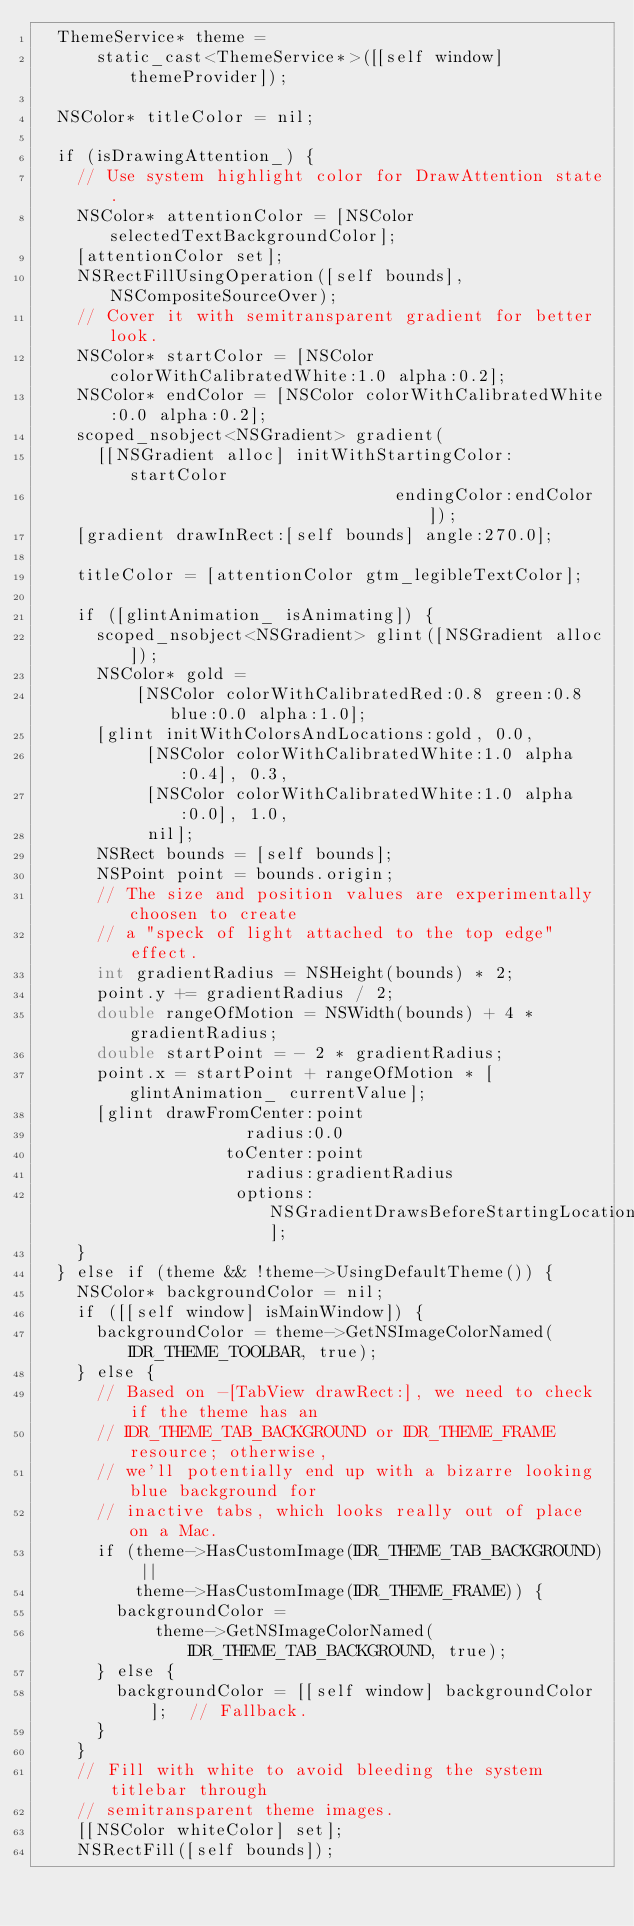<code> <loc_0><loc_0><loc_500><loc_500><_ObjectiveC_>  ThemeService* theme =
      static_cast<ThemeService*>([[self window] themeProvider]);

  NSColor* titleColor = nil;

  if (isDrawingAttention_) {
    // Use system highlight color for DrawAttention state.
    NSColor* attentionColor = [NSColor selectedTextBackgroundColor];
    [attentionColor set];
    NSRectFillUsingOperation([self bounds], NSCompositeSourceOver);
    // Cover it with semitransparent gradient for better look.
    NSColor* startColor = [NSColor colorWithCalibratedWhite:1.0 alpha:0.2];
    NSColor* endColor = [NSColor colorWithCalibratedWhite:0.0 alpha:0.2];
    scoped_nsobject<NSGradient> gradient(
      [[NSGradient alloc] initWithStartingColor:startColor
                                    endingColor:endColor]);
    [gradient drawInRect:[self bounds] angle:270.0];

    titleColor = [attentionColor gtm_legibleTextColor];

    if ([glintAnimation_ isAnimating]) {
      scoped_nsobject<NSGradient> glint([NSGradient alloc]);
      NSColor* gold =
          [NSColor colorWithCalibratedRed:0.8 green:0.8 blue:0.0 alpha:1.0];
      [glint initWithColorsAndLocations:gold, 0.0,
           [NSColor colorWithCalibratedWhite:1.0 alpha:0.4], 0.3,
           [NSColor colorWithCalibratedWhite:1.0 alpha:0.0], 1.0,
           nil];
      NSRect bounds = [self bounds];
      NSPoint point = bounds.origin;
      // The size and position values are experimentally choosen to create
      // a "speck of light attached to the top edge" effect.
      int gradientRadius = NSHeight(bounds) * 2;
      point.y += gradientRadius / 2;
      double rangeOfMotion = NSWidth(bounds) + 4 * gradientRadius;
      double startPoint = - 2 * gradientRadius;
      point.x = startPoint + rangeOfMotion * [glintAnimation_ currentValue];
      [glint drawFromCenter:point
                     radius:0.0
                   toCenter:point
                     radius:gradientRadius
                    options:NSGradientDrawsBeforeStartingLocation];
    }
  } else if (theme && !theme->UsingDefaultTheme()) {
    NSColor* backgroundColor = nil;
    if ([[self window] isMainWindow]) {
      backgroundColor = theme->GetNSImageColorNamed(IDR_THEME_TOOLBAR, true);
    } else {
      // Based on -[TabView drawRect:], we need to check if the theme has an
      // IDR_THEME_TAB_BACKGROUND or IDR_THEME_FRAME resource; otherwise,
      // we'll potentially end up with a bizarre looking blue background for
      // inactive tabs, which looks really out of place on a Mac.
      if (theme->HasCustomImage(IDR_THEME_TAB_BACKGROUND) ||
          theme->HasCustomImage(IDR_THEME_FRAME)) {
        backgroundColor =
            theme->GetNSImageColorNamed(IDR_THEME_TAB_BACKGROUND, true);
      } else {
        backgroundColor = [[self window] backgroundColor];  // Fallback.
      }
    }
    // Fill with white to avoid bleeding the system titlebar through
    // semitransparent theme images.
    [[NSColor whiteColor] set];
    NSRectFill([self bounds]);
</code> 